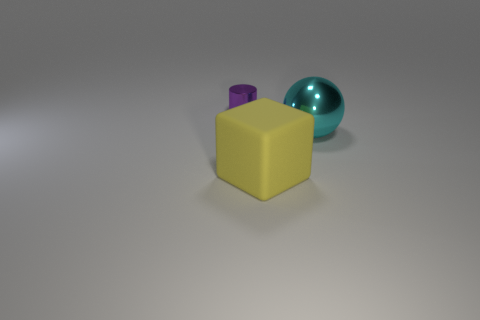Are there any other things that are the same size as the metallic cylinder?
Provide a succinct answer. No. There is a thing on the right side of the thing in front of the metal thing to the right of the purple metal cylinder; what size is it?
Your response must be concise. Large. What is the material of the big yellow object?
Your answer should be very brief. Rubber. What number of shiny objects are big cubes or green spheres?
Offer a terse response. 0. Is the number of spheres that are in front of the cyan object less than the number of large objects that are in front of the tiny purple cylinder?
Offer a very short reply. Yes. There is a metal thing on the right side of the shiny thing left of the big shiny ball; are there any big yellow matte objects that are right of it?
Your answer should be very brief. No. What material is the cube that is the same size as the cyan ball?
Offer a terse response. Rubber. Is the material of the thing that is behind the cyan object the same as the thing to the right of the yellow matte object?
Offer a very short reply. Yes. There is a metal thing that is the same size as the rubber thing; what is its shape?
Make the answer very short. Sphere. What number of other things are the same color as the rubber thing?
Ensure brevity in your answer.  0. 